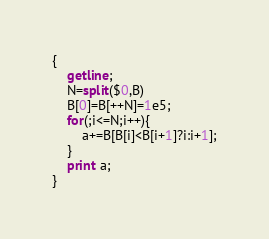<code> <loc_0><loc_0><loc_500><loc_500><_Awk_>{
    getline;
    N=split($0,B)
    B[0]=B[++N]=1e5;
    for(;i<=N;i++){
        a+=B[B[i]<B[i+1]?i:i+1];
    }
    print a;
}</code> 